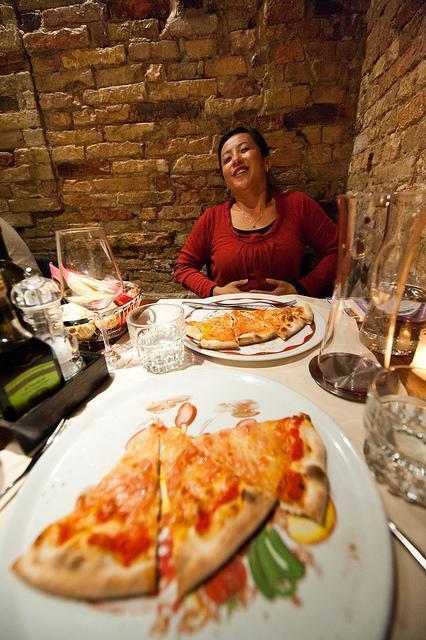What type of food is served here?
Answer the question by selecting the correct answer among the 4 following choices and explain your choice with a short sentence. The answer should be formatted with the following format: `Answer: choice
Rationale: rationale.`
Options: Italian, thai, korean, chinese. Answer: italian.
Rationale: Pizza is on a white plate on a table. 